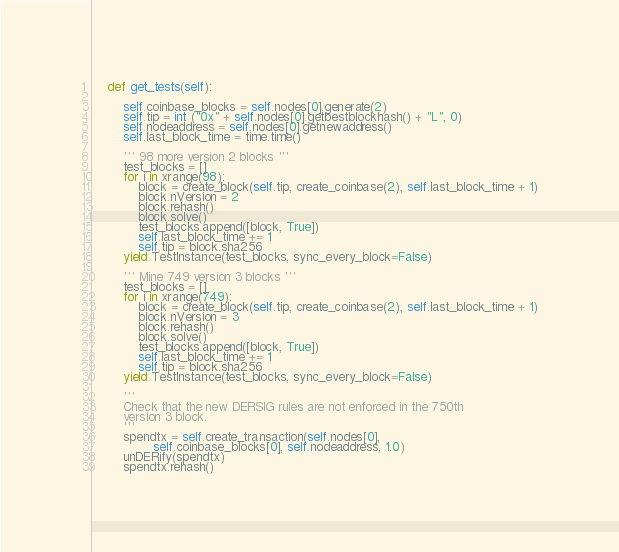Convert code to text. <code><loc_0><loc_0><loc_500><loc_500><_Python_>
    def get_tests(self):

        self.coinbase_blocks = self.nodes[0].generate(2)
        self.tip = int ("0x" + self.nodes[0].getbestblockhash() + "L", 0)
        self.nodeaddress = self.nodes[0].getnewaddress()
        self.last_block_time = time.time()

        ''' 98 more version 2 blocks '''
        test_blocks = []
        for i in xrange(98):
            block = create_block(self.tip, create_coinbase(2), self.last_block_time + 1)
            block.nVersion = 2
            block.rehash()
            block.solve()
            test_blocks.append([block, True])
            self.last_block_time += 1
            self.tip = block.sha256
        yield TestInstance(test_blocks, sync_every_block=False)

        ''' Mine 749 version 3 blocks '''
        test_blocks = []
        for i in xrange(749):
            block = create_block(self.tip, create_coinbase(2), self.last_block_time + 1)
            block.nVersion = 3
            block.rehash()
            block.solve()
            test_blocks.append([block, True])
            self.last_block_time += 1
            self.tip = block.sha256
        yield TestInstance(test_blocks, sync_every_block=False)

        ''' 
        Check that the new DERSIG rules are not enforced in the 750th
        version 3 block.
        '''
        spendtx = self.create_transaction(self.nodes[0],
                self.coinbase_blocks[0], self.nodeaddress, 1.0)
        unDERify(spendtx)
        spendtx.rehash()
</code> 